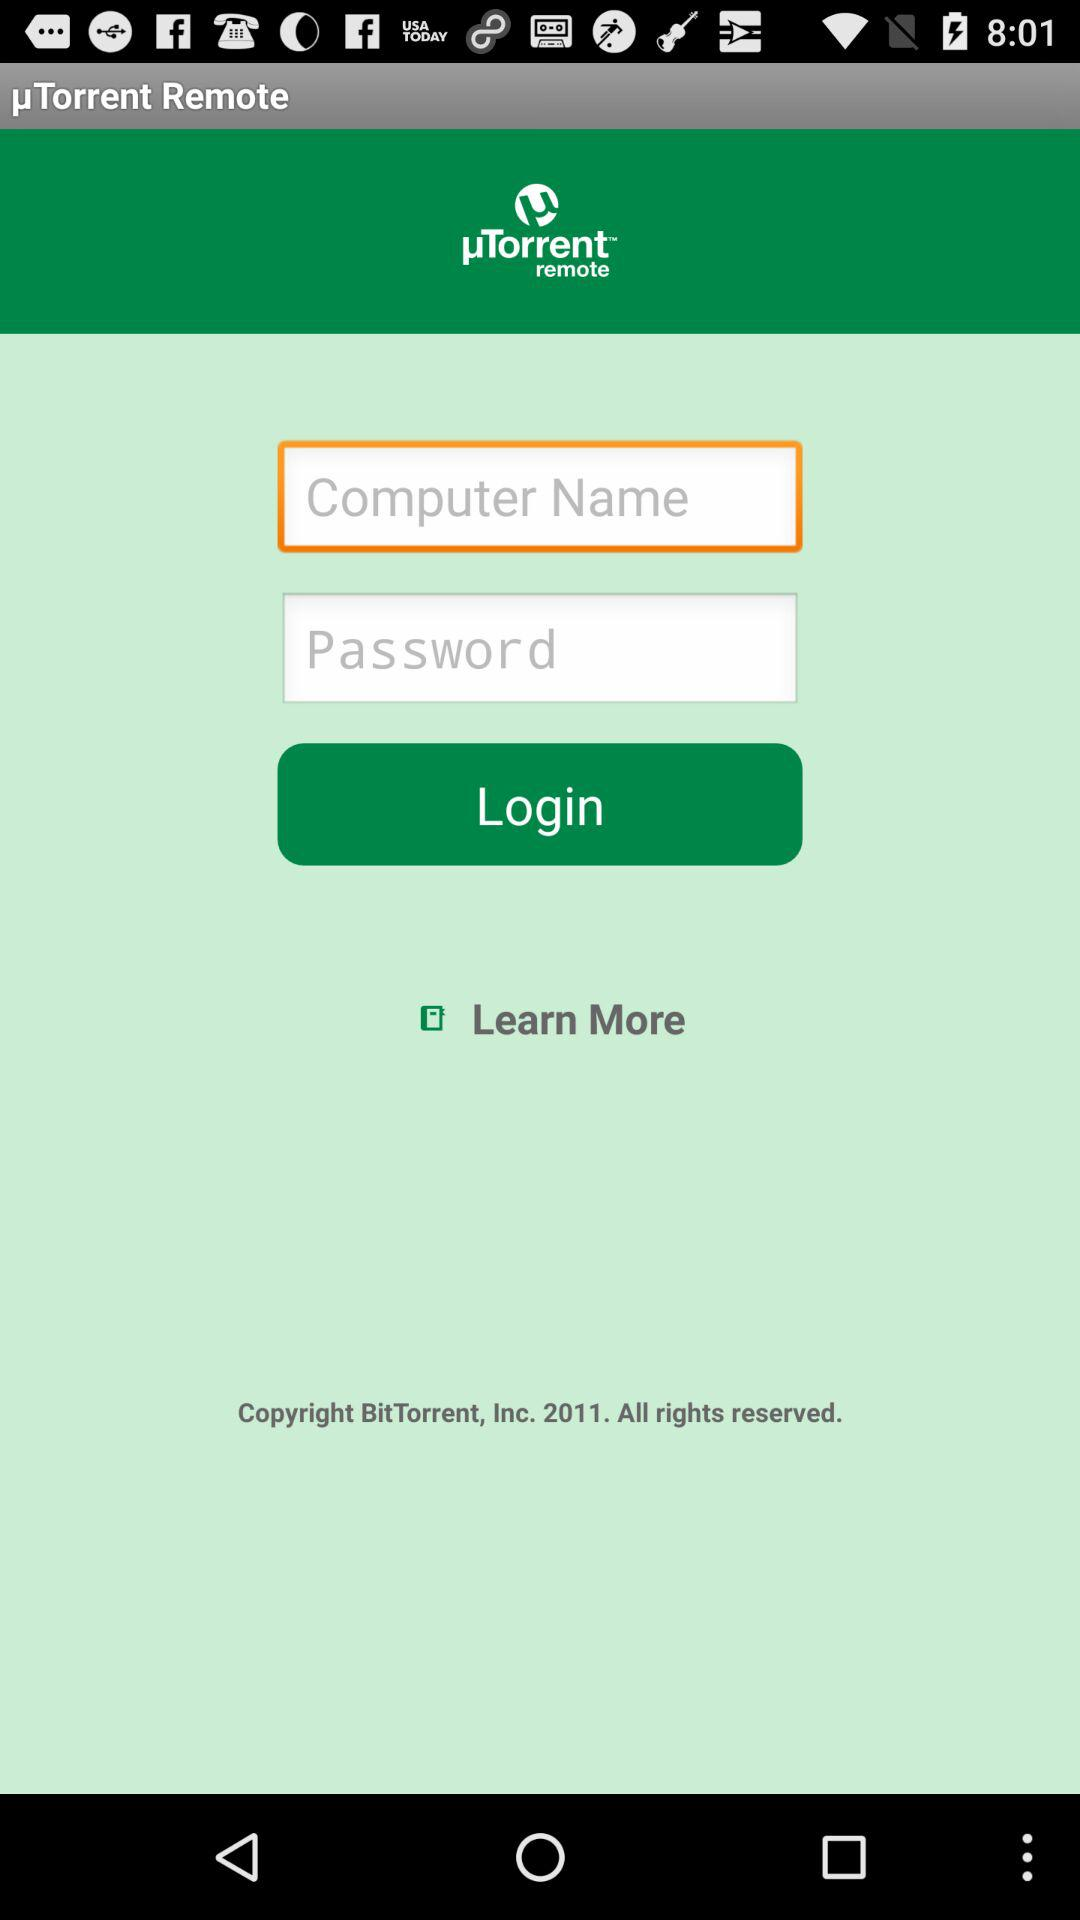How many items are there in the login form?
Answer the question using a single word or phrase. 2 